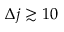<formula> <loc_0><loc_0><loc_500><loc_500>\Delta j \gtrsim 1 0</formula> 